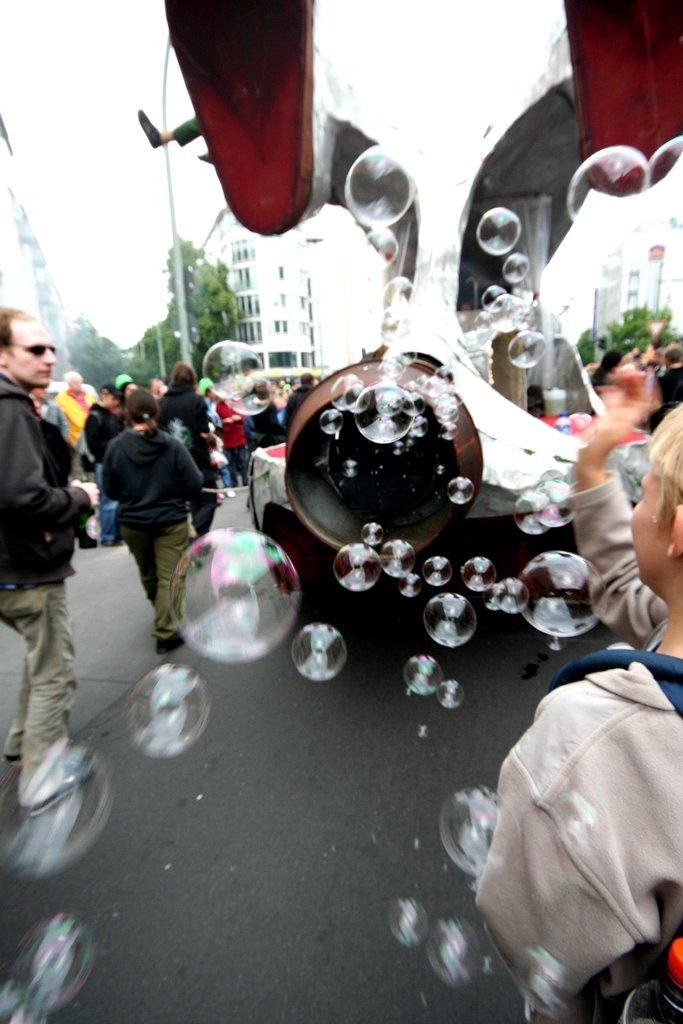Who or what can be seen in the image? There are people in the image. What structures are visible in the image? There are buildings in the image. What type of vegetation is present in the image? There are trees in the image. What other objects can be seen in the image? There are poles in the image. What is visible in the background of the image? The sky is visible in the image. What objects are being used for recreational purposes in the image? There are water balloons in the image. What type of pathway is present in the image? There is a road in the image. Where is the jar of pickles located in the image? There is no jar of pickles present in the image. How many tickets are visible in the image? There are no tickets visible in the image. 